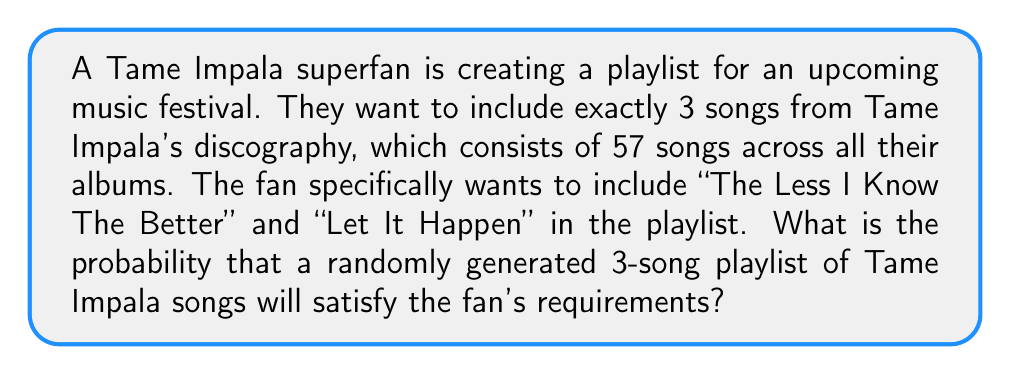Could you help me with this problem? Let's approach this step-by-step:

1) We know that two specific songs must be included: "The Less I Know The Better" and "Let It Happen". This means we only need to randomly select one more song from the remaining songs.

2) The total number of songs in Tame Impala's discography is 57.

3) After including the two required songs, we have 55 songs left to choose from for the third spot.

4) We can calculate this probability using the following formula:

   $$P(\text{desired playlist}) = \frac{\text{number of favorable outcomes}}{\text{total number of possible outcomes}}$$

5) The number of favorable outcomes is the number of ways to choose 1 song from the remaining 55 songs, which is simply 55.

6) The total number of possible outcomes is the number of ways to choose 3 songs from 57 songs, which can be calculated using the combination formula:

   $$\binom{57}{3} = \frac{57!}{3!(57-3)!} = \frac{57!}{3!54!} = 29260$$

7) Therefore, the probability is:

   $$P(\text{desired playlist}) = \frac{55}{29260}$$

8) This can be simplified to:

   $$P(\text{desired playlist}) = \frac{11}{5852} \approx 0.001880$$
Answer: The probability is $\frac{11}{5852}$ or approximately 0.001880 (0.1880%). 